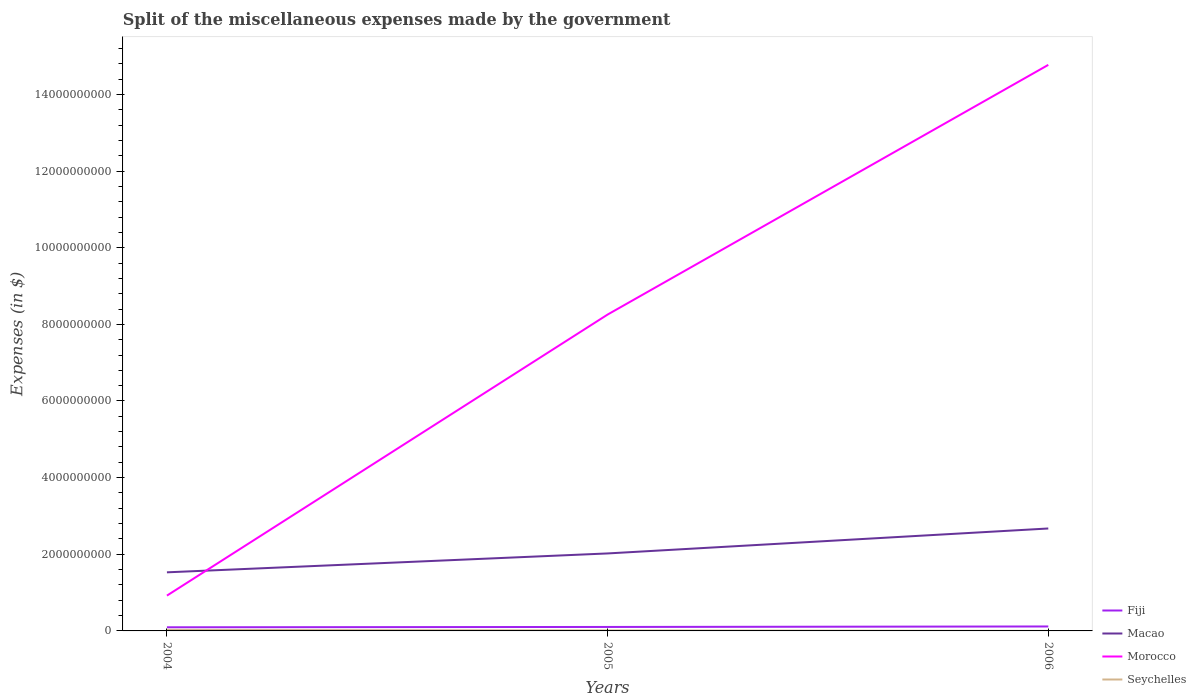Does the line corresponding to Morocco intersect with the line corresponding to Fiji?
Your answer should be compact. No. Across all years, what is the maximum miscellaneous expenses made by the government in Macao?
Ensure brevity in your answer.  1.53e+09. What is the total miscellaneous expenses made by the government in Morocco in the graph?
Make the answer very short. -1.38e+1. What is the difference between the highest and the second highest miscellaneous expenses made by the government in Fiji?
Your response must be concise. 2.09e+07. What is the difference between the highest and the lowest miscellaneous expenses made by the government in Fiji?
Give a very brief answer. 1. What is the difference between two consecutive major ticks on the Y-axis?
Provide a succinct answer. 2.00e+09. Are the values on the major ticks of Y-axis written in scientific E-notation?
Your response must be concise. No. Does the graph contain grids?
Give a very brief answer. No. Where does the legend appear in the graph?
Your answer should be very brief. Bottom right. What is the title of the graph?
Your response must be concise. Split of the miscellaneous expenses made by the government. What is the label or title of the Y-axis?
Offer a very short reply. Expenses (in $). What is the Expenses (in $) in Fiji in 2004?
Ensure brevity in your answer.  9.51e+07. What is the Expenses (in $) in Macao in 2004?
Keep it short and to the point. 1.53e+09. What is the Expenses (in $) of Morocco in 2004?
Your answer should be compact. 9.22e+08. What is the Expenses (in $) in Seychelles in 2004?
Provide a short and direct response. 2.72e+07. What is the Expenses (in $) in Fiji in 2005?
Ensure brevity in your answer.  1.04e+08. What is the Expenses (in $) in Macao in 2005?
Offer a terse response. 2.02e+09. What is the Expenses (in $) of Morocco in 2005?
Provide a succinct answer. 8.26e+09. What is the Expenses (in $) of Seychelles in 2005?
Ensure brevity in your answer.  1.26e+07. What is the Expenses (in $) of Fiji in 2006?
Provide a short and direct response. 1.16e+08. What is the Expenses (in $) in Macao in 2006?
Keep it short and to the point. 2.67e+09. What is the Expenses (in $) of Morocco in 2006?
Make the answer very short. 1.48e+1. What is the Expenses (in $) of Seychelles in 2006?
Provide a short and direct response. 8.00e+05. Across all years, what is the maximum Expenses (in $) in Fiji?
Offer a very short reply. 1.16e+08. Across all years, what is the maximum Expenses (in $) of Macao?
Your response must be concise. 2.67e+09. Across all years, what is the maximum Expenses (in $) of Morocco?
Make the answer very short. 1.48e+1. Across all years, what is the maximum Expenses (in $) of Seychelles?
Your answer should be compact. 2.72e+07. Across all years, what is the minimum Expenses (in $) of Fiji?
Offer a terse response. 9.51e+07. Across all years, what is the minimum Expenses (in $) of Macao?
Offer a very short reply. 1.53e+09. Across all years, what is the minimum Expenses (in $) in Morocco?
Ensure brevity in your answer.  9.22e+08. Across all years, what is the minimum Expenses (in $) of Seychelles?
Provide a succinct answer. 8.00e+05. What is the total Expenses (in $) in Fiji in the graph?
Ensure brevity in your answer.  3.15e+08. What is the total Expenses (in $) of Macao in the graph?
Offer a terse response. 6.22e+09. What is the total Expenses (in $) of Morocco in the graph?
Offer a terse response. 2.39e+1. What is the total Expenses (in $) in Seychelles in the graph?
Offer a very short reply. 4.06e+07. What is the difference between the Expenses (in $) in Fiji in 2004 and that in 2005?
Provide a short and direct response. -8.37e+06. What is the difference between the Expenses (in $) in Macao in 2004 and that in 2005?
Keep it short and to the point. -4.93e+08. What is the difference between the Expenses (in $) in Morocco in 2004 and that in 2005?
Offer a terse response. -7.33e+09. What is the difference between the Expenses (in $) in Seychelles in 2004 and that in 2005?
Give a very brief answer. 1.46e+07. What is the difference between the Expenses (in $) in Fiji in 2004 and that in 2006?
Provide a short and direct response. -2.09e+07. What is the difference between the Expenses (in $) in Macao in 2004 and that in 2006?
Your response must be concise. -1.14e+09. What is the difference between the Expenses (in $) in Morocco in 2004 and that in 2006?
Your answer should be very brief. -1.38e+1. What is the difference between the Expenses (in $) of Seychelles in 2004 and that in 2006?
Your response must be concise. 2.64e+07. What is the difference between the Expenses (in $) of Fiji in 2005 and that in 2006?
Give a very brief answer. -1.25e+07. What is the difference between the Expenses (in $) of Macao in 2005 and that in 2006?
Offer a terse response. -6.51e+08. What is the difference between the Expenses (in $) in Morocco in 2005 and that in 2006?
Your answer should be compact. -6.52e+09. What is the difference between the Expenses (in $) in Seychelles in 2005 and that in 2006?
Ensure brevity in your answer.  1.18e+07. What is the difference between the Expenses (in $) of Fiji in 2004 and the Expenses (in $) of Macao in 2005?
Provide a succinct answer. -1.93e+09. What is the difference between the Expenses (in $) of Fiji in 2004 and the Expenses (in $) of Morocco in 2005?
Ensure brevity in your answer.  -8.16e+09. What is the difference between the Expenses (in $) in Fiji in 2004 and the Expenses (in $) in Seychelles in 2005?
Offer a terse response. 8.25e+07. What is the difference between the Expenses (in $) in Macao in 2004 and the Expenses (in $) in Morocco in 2005?
Your answer should be very brief. -6.73e+09. What is the difference between the Expenses (in $) in Macao in 2004 and the Expenses (in $) in Seychelles in 2005?
Give a very brief answer. 1.52e+09. What is the difference between the Expenses (in $) in Morocco in 2004 and the Expenses (in $) in Seychelles in 2005?
Provide a short and direct response. 9.09e+08. What is the difference between the Expenses (in $) of Fiji in 2004 and the Expenses (in $) of Macao in 2006?
Your answer should be very brief. -2.58e+09. What is the difference between the Expenses (in $) of Fiji in 2004 and the Expenses (in $) of Morocco in 2006?
Provide a short and direct response. -1.47e+1. What is the difference between the Expenses (in $) of Fiji in 2004 and the Expenses (in $) of Seychelles in 2006?
Your response must be concise. 9.43e+07. What is the difference between the Expenses (in $) of Macao in 2004 and the Expenses (in $) of Morocco in 2006?
Give a very brief answer. -1.32e+1. What is the difference between the Expenses (in $) of Macao in 2004 and the Expenses (in $) of Seychelles in 2006?
Your response must be concise. 1.53e+09. What is the difference between the Expenses (in $) in Morocco in 2004 and the Expenses (in $) in Seychelles in 2006?
Give a very brief answer. 9.21e+08. What is the difference between the Expenses (in $) in Fiji in 2005 and the Expenses (in $) in Macao in 2006?
Your answer should be compact. -2.57e+09. What is the difference between the Expenses (in $) of Fiji in 2005 and the Expenses (in $) of Morocco in 2006?
Offer a terse response. -1.47e+1. What is the difference between the Expenses (in $) in Fiji in 2005 and the Expenses (in $) in Seychelles in 2006?
Offer a terse response. 1.03e+08. What is the difference between the Expenses (in $) in Macao in 2005 and the Expenses (in $) in Morocco in 2006?
Give a very brief answer. -1.27e+1. What is the difference between the Expenses (in $) of Macao in 2005 and the Expenses (in $) of Seychelles in 2006?
Give a very brief answer. 2.02e+09. What is the difference between the Expenses (in $) in Morocco in 2005 and the Expenses (in $) in Seychelles in 2006?
Your response must be concise. 8.25e+09. What is the average Expenses (in $) in Fiji per year?
Provide a short and direct response. 1.05e+08. What is the average Expenses (in $) of Macao per year?
Provide a succinct answer. 2.07e+09. What is the average Expenses (in $) in Morocco per year?
Give a very brief answer. 7.98e+09. What is the average Expenses (in $) of Seychelles per year?
Offer a very short reply. 1.36e+07. In the year 2004, what is the difference between the Expenses (in $) in Fiji and Expenses (in $) in Macao?
Offer a very short reply. -1.43e+09. In the year 2004, what is the difference between the Expenses (in $) of Fiji and Expenses (in $) of Morocco?
Provide a succinct answer. -8.26e+08. In the year 2004, what is the difference between the Expenses (in $) in Fiji and Expenses (in $) in Seychelles?
Ensure brevity in your answer.  6.79e+07. In the year 2004, what is the difference between the Expenses (in $) of Macao and Expenses (in $) of Morocco?
Ensure brevity in your answer.  6.07e+08. In the year 2004, what is the difference between the Expenses (in $) in Macao and Expenses (in $) in Seychelles?
Provide a short and direct response. 1.50e+09. In the year 2004, what is the difference between the Expenses (in $) in Morocco and Expenses (in $) in Seychelles?
Offer a very short reply. 8.94e+08. In the year 2005, what is the difference between the Expenses (in $) of Fiji and Expenses (in $) of Macao?
Ensure brevity in your answer.  -1.92e+09. In the year 2005, what is the difference between the Expenses (in $) of Fiji and Expenses (in $) of Morocco?
Provide a succinct answer. -8.15e+09. In the year 2005, what is the difference between the Expenses (in $) in Fiji and Expenses (in $) in Seychelles?
Keep it short and to the point. 9.08e+07. In the year 2005, what is the difference between the Expenses (in $) of Macao and Expenses (in $) of Morocco?
Give a very brief answer. -6.23e+09. In the year 2005, what is the difference between the Expenses (in $) in Macao and Expenses (in $) in Seychelles?
Provide a short and direct response. 2.01e+09. In the year 2005, what is the difference between the Expenses (in $) of Morocco and Expenses (in $) of Seychelles?
Provide a short and direct response. 8.24e+09. In the year 2006, what is the difference between the Expenses (in $) of Fiji and Expenses (in $) of Macao?
Keep it short and to the point. -2.56e+09. In the year 2006, what is the difference between the Expenses (in $) of Fiji and Expenses (in $) of Morocco?
Your answer should be very brief. -1.47e+1. In the year 2006, what is the difference between the Expenses (in $) of Fiji and Expenses (in $) of Seychelles?
Make the answer very short. 1.15e+08. In the year 2006, what is the difference between the Expenses (in $) of Macao and Expenses (in $) of Morocco?
Give a very brief answer. -1.21e+1. In the year 2006, what is the difference between the Expenses (in $) of Macao and Expenses (in $) of Seychelles?
Provide a short and direct response. 2.67e+09. In the year 2006, what is the difference between the Expenses (in $) of Morocco and Expenses (in $) of Seychelles?
Give a very brief answer. 1.48e+1. What is the ratio of the Expenses (in $) in Fiji in 2004 to that in 2005?
Ensure brevity in your answer.  0.92. What is the ratio of the Expenses (in $) of Macao in 2004 to that in 2005?
Your answer should be very brief. 0.76. What is the ratio of the Expenses (in $) of Morocco in 2004 to that in 2005?
Keep it short and to the point. 0.11. What is the ratio of the Expenses (in $) in Seychelles in 2004 to that in 2005?
Ensure brevity in your answer.  2.15. What is the ratio of the Expenses (in $) of Fiji in 2004 to that in 2006?
Provide a succinct answer. 0.82. What is the ratio of the Expenses (in $) of Macao in 2004 to that in 2006?
Give a very brief answer. 0.57. What is the ratio of the Expenses (in $) in Morocco in 2004 to that in 2006?
Your response must be concise. 0.06. What is the ratio of the Expenses (in $) in Fiji in 2005 to that in 2006?
Offer a very short reply. 0.89. What is the ratio of the Expenses (in $) in Macao in 2005 to that in 2006?
Provide a short and direct response. 0.76. What is the ratio of the Expenses (in $) in Morocco in 2005 to that in 2006?
Keep it short and to the point. 0.56. What is the ratio of the Expenses (in $) in Seychelles in 2005 to that in 2006?
Keep it short and to the point. 15.81. What is the difference between the highest and the second highest Expenses (in $) in Fiji?
Offer a terse response. 1.25e+07. What is the difference between the highest and the second highest Expenses (in $) in Macao?
Make the answer very short. 6.51e+08. What is the difference between the highest and the second highest Expenses (in $) in Morocco?
Provide a short and direct response. 6.52e+09. What is the difference between the highest and the second highest Expenses (in $) in Seychelles?
Your answer should be very brief. 1.46e+07. What is the difference between the highest and the lowest Expenses (in $) in Fiji?
Your response must be concise. 2.09e+07. What is the difference between the highest and the lowest Expenses (in $) of Macao?
Ensure brevity in your answer.  1.14e+09. What is the difference between the highest and the lowest Expenses (in $) of Morocco?
Keep it short and to the point. 1.38e+1. What is the difference between the highest and the lowest Expenses (in $) of Seychelles?
Ensure brevity in your answer.  2.64e+07. 